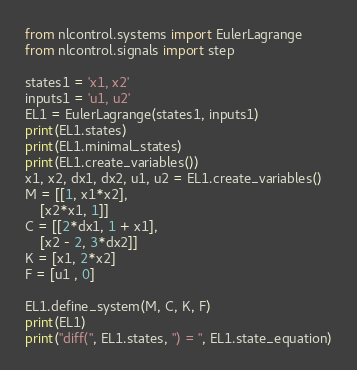<code> <loc_0><loc_0><loc_500><loc_500><_Python_>from nlcontrol.systems import EulerLagrange
from nlcontrol.signals import step

states1 = 'x1, x2'
inputs1 = 'u1, u2'
EL1 = EulerLagrange(states1, inputs1)
print(EL1.states)
print(EL1.minimal_states)
print(EL1.create_variables())
x1, x2, dx1, dx2, u1, u2 = EL1.create_variables()
M = [[1, x1*x2],
    [x2*x1, 1]]
C = [[2*dx1, 1 + x1],
    [x2 - 2, 3*dx2]]
K = [x1, 2*x2]
F = [u1 , 0]

EL1.define_system(M, C, K, F)
print(EL1)
print("diff(", EL1.states, ") = ", EL1.state_equation)
</code> 